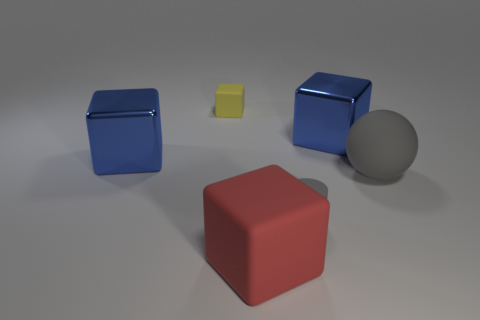Add 2 tiny yellow cubes. How many objects exist? 8 Subtract all balls. How many objects are left? 5 Add 1 tiny gray cylinders. How many tiny gray cylinders exist? 2 Subtract 0 purple balls. How many objects are left? 6 Subtract all small yellow rubber things. Subtract all big brown shiny cylinders. How many objects are left? 5 Add 1 cylinders. How many cylinders are left? 2 